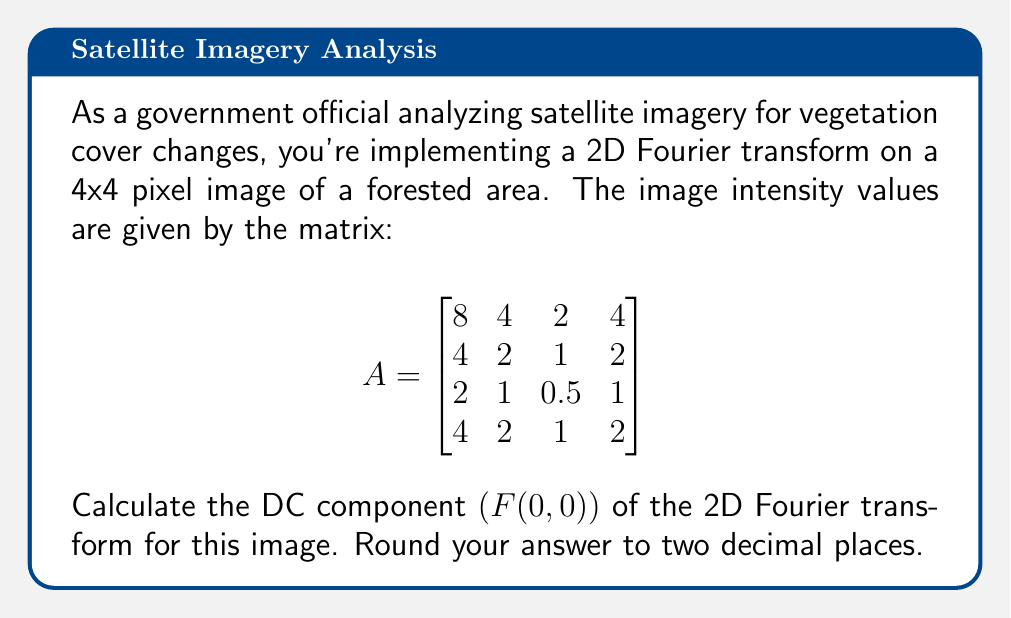Help me with this question. To calculate the DC component of the 2D Fourier transform, we need to follow these steps:

1) The DC component F(0,0) represents the average intensity of the image. It is calculated using the formula:

   $$F(0,0) = \frac{1}{MN} \sum_{x=0}^{M-1} \sum_{y=0}^{N-1} f(x,y)$$

   where M and N are the dimensions of the image, and f(x,y) represents the pixel intensity at position (x,y).

2) In our case, M = N = 4, so we have:

   $$F(0,0) = \frac{1}{4 \times 4} \sum_{x=0}^{3} \sum_{y=0}^{3} f(x,y)$$

3) Now, we sum all the elements in the matrix:

   $$\sum_{x=0}^{3} \sum_{y=0}^{3} f(x,y) = 8 + 4 + 2 + 4 + 4 + 2 + 1 + 2 + 2 + 1 + 0.5 + 1 + 4 + 2 + 1 + 2$$

4) Adding these up:

   $$\sum_{x=0}^{3} \sum_{y=0}^{3} f(x,y) = 40.5$$

5) Now, we divide by the total number of pixels (16):

   $$F(0,0) = \frac{40.5}{16} = 2.53125$$

6) Rounding to two decimal places:

   $$F(0,0) \approx 2.53$$

This value represents the average intensity of the forest cover in the satellite image, which can be used as a baseline for tracking changes over time.
Answer: 2.53 